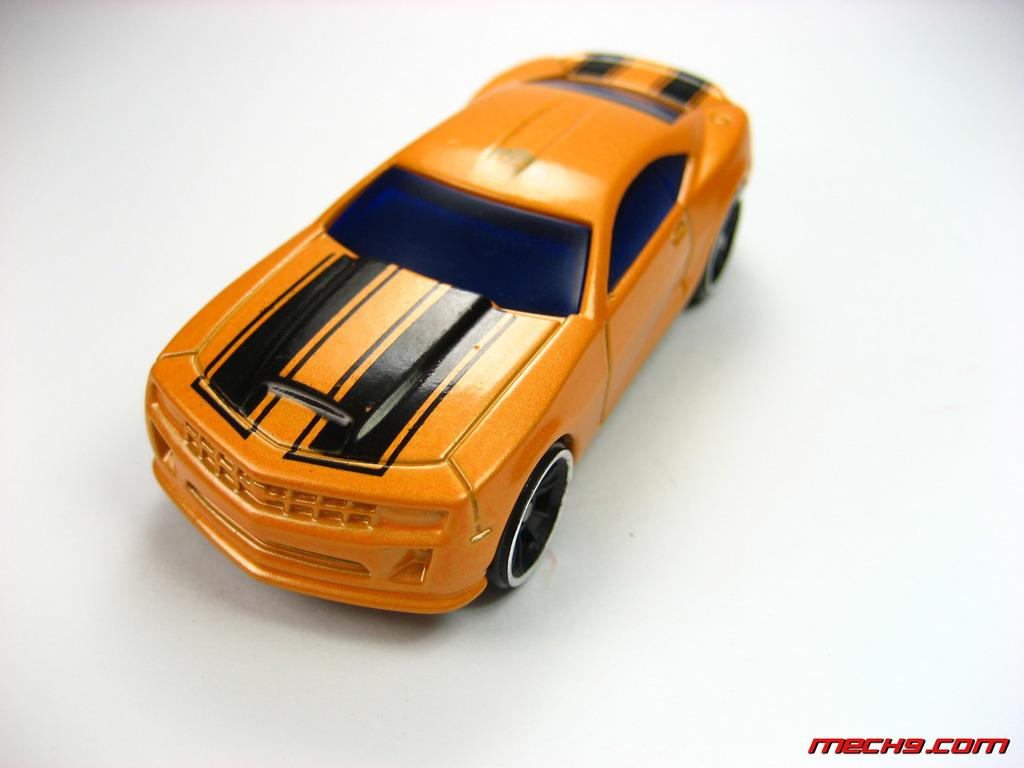What type of toy is in the image? There is a yellow toy vehicle in the image. What is the toy vehicle resting on? The toy vehicle is on a surface. Is there any text or marking in the image? Yes, there is a red watermark in the bottom right corner of the image. What color is the background of the image? The background of the image is white. How much profit does the toy vehicle generate in the image? The image does not provide any information about the toy vehicle's profitability, as it is a static image and not a real-life scenario. 